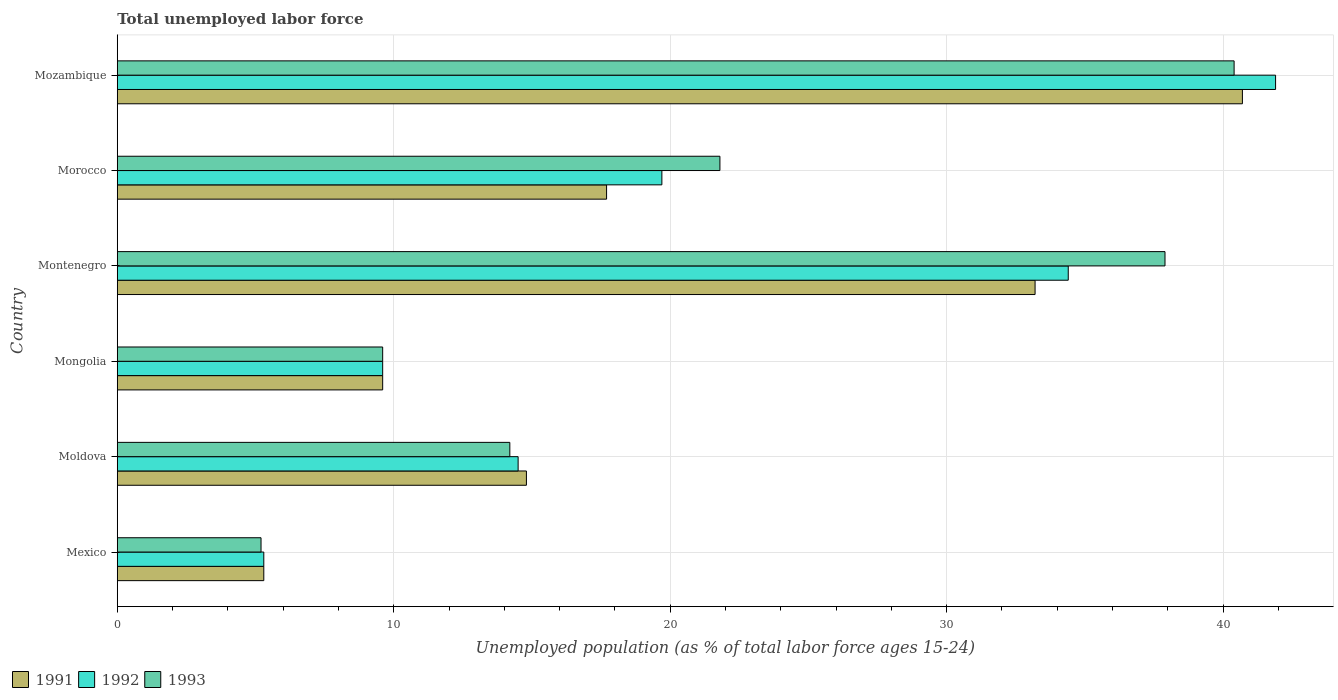How many different coloured bars are there?
Your answer should be compact. 3. How many bars are there on the 4th tick from the top?
Give a very brief answer. 3. How many bars are there on the 6th tick from the bottom?
Give a very brief answer. 3. What is the label of the 3rd group of bars from the top?
Offer a very short reply. Montenegro. In how many cases, is the number of bars for a given country not equal to the number of legend labels?
Keep it short and to the point. 0. What is the percentage of unemployed population in in 1992 in Morocco?
Give a very brief answer. 19.7. Across all countries, what is the maximum percentage of unemployed population in in 1991?
Give a very brief answer. 40.7. Across all countries, what is the minimum percentage of unemployed population in in 1992?
Provide a short and direct response. 5.3. In which country was the percentage of unemployed population in in 1993 maximum?
Ensure brevity in your answer.  Mozambique. What is the total percentage of unemployed population in in 1993 in the graph?
Give a very brief answer. 129.1. What is the difference between the percentage of unemployed population in in 1992 in Mexico and that in Montenegro?
Ensure brevity in your answer.  -29.1. What is the difference between the percentage of unemployed population in in 1992 in Morocco and the percentage of unemployed population in in 1993 in Mexico?
Provide a short and direct response. 14.5. What is the average percentage of unemployed population in in 1991 per country?
Ensure brevity in your answer.  20.22. What is the ratio of the percentage of unemployed population in in 1992 in Mexico to that in Mongolia?
Your response must be concise. 0.55. What is the difference between the highest and the lowest percentage of unemployed population in in 1991?
Give a very brief answer. 35.4. In how many countries, is the percentage of unemployed population in in 1993 greater than the average percentage of unemployed population in in 1993 taken over all countries?
Make the answer very short. 3. What does the 2nd bar from the bottom in Mongolia represents?
Provide a succinct answer. 1992. How many bars are there?
Provide a succinct answer. 18. Are the values on the major ticks of X-axis written in scientific E-notation?
Give a very brief answer. No. Does the graph contain any zero values?
Ensure brevity in your answer.  No. Does the graph contain grids?
Give a very brief answer. Yes. Where does the legend appear in the graph?
Give a very brief answer. Bottom left. How many legend labels are there?
Offer a very short reply. 3. How are the legend labels stacked?
Make the answer very short. Horizontal. What is the title of the graph?
Make the answer very short. Total unemployed labor force. What is the label or title of the X-axis?
Offer a very short reply. Unemployed population (as % of total labor force ages 15-24). What is the label or title of the Y-axis?
Make the answer very short. Country. What is the Unemployed population (as % of total labor force ages 15-24) of 1991 in Mexico?
Offer a very short reply. 5.3. What is the Unemployed population (as % of total labor force ages 15-24) in 1992 in Mexico?
Offer a terse response. 5.3. What is the Unemployed population (as % of total labor force ages 15-24) of 1993 in Mexico?
Provide a succinct answer. 5.2. What is the Unemployed population (as % of total labor force ages 15-24) in 1991 in Moldova?
Keep it short and to the point. 14.8. What is the Unemployed population (as % of total labor force ages 15-24) in 1993 in Moldova?
Offer a very short reply. 14.2. What is the Unemployed population (as % of total labor force ages 15-24) of 1991 in Mongolia?
Your answer should be very brief. 9.6. What is the Unemployed population (as % of total labor force ages 15-24) of 1992 in Mongolia?
Your response must be concise. 9.6. What is the Unemployed population (as % of total labor force ages 15-24) in 1993 in Mongolia?
Your answer should be compact. 9.6. What is the Unemployed population (as % of total labor force ages 15-24) in 1991 in Montenegro?
Provide a succinct answer. 33.2. What is the Unemployed population (as % of total labor force ages 15-24) in 1992 in Montenegro?
Keep it short and to the point. 34.4. What is the Unemployed population (as % of total labor force ages 15-24) in 1993 in Montenegro?
Make the answer very short. 37.9. What is the Unemployed population (as % of total labor force ages 15-24) of 1991 in Morocco?
Provide a short and direct response. 17.7. What is the Unemployed population (as % of total labor force ages 15-24) of 1992 in Morocco?
Give a very brief answer. 19.7. What is the Unemployed population (as % of total labor force ages 15-24) in 1993 in Morocco?
Your answer should be very brief. 21.8. What is the Unemployed population (as % of total labor force ages 15-24) of 1991 in Mozambique?
Offer a very short reply. 40.7. What is the Unemployed population (as % of total labor force ages 15-24) of 1992 in Mozambique?
Provide a short and direct response. 41.9. What is the Unemployed population (as % of total labor force ages 15-24) of 1993 in Mozambique?
Your answer should be compact. 40.4. Across all countries, what is the maximum Unemployed population (as % of total labor force ages 15-24) of 1991?
Make the answer very short. 40.7. Across all countries, what is the maximum Unemployed population (as % of total labor force ages 15-24) of 1992?
Your answer should be very brief. 41.9. Across all countries, what is the maximum Unemployed population (as % of total labor force ages 15-24) of 1993?
Give a very brief answer. 40.4. Across all countries, what is the minimum Unemployed population (as % of total labor force ages 15-24) in 1991?
Your response must be concise. 5.3. Across all countries, what is the minimum Unemployed population (as % of total labor force ages 15-24) of 1992?
Keep it short and to the point. 5.3. Across all countries, what is the minimum Unemployed population (as % of total labor force ages 15-24) in 1993?
Keep it short and to the point. 5.2. What is the total Unemployed population (as % of total labor force ages 15-24) of 1991 in the graph?
Keep it short and to the point. 121.3. What is the total Unemployed population (as % of total labor force ages 15-24) of 1992 in the graph?
Offer a very short reply. 125.4. What is the total Unemployed population (as % of total labor force ages 15-24) of 1993 in the graph?
Give a very brief answer. 129.1. What is the difference between the Unemployed population (as % of total labor force ages 15-24) in 1992 in Mexico and that in Moldova?
Your response must be concise. -9.2. What is the difference between the Unemployed population (as % of total labor force ages 15-24) of 1993 in Mexico and that in Moldova?
Offer a terse response. -9. What is the difference between the Unemployed population (as % of total labor force ages 15-24) of 1991 in Mexico and that in Mongolia?
Your answer should be very brief. -4.3. What is the difference between the Unemployed population (as % of total labor force ages 15-24) in 1993 in Mexico and that in Mongolia?
Your answer should be very brief. -4.4. What is the difference between the Unemployed population (as % of total labor force ages 15-24) of 1991 in Mexico and that in Montenegro?
Offer a very short reply. -27.9. What is the difference between the Unemployed population (as % of total labor force ages 15-24) in 1992 in Mexico and that in Montenegro?
Give a very brief answer. -29.1. What is the difference between the Unemployed population (as % of total labor force ages 15-24) in 1993 in Mexico and that in Montenegro?
Make the answer very short. -32.7. What is the difference between the Unemployed population (as % of total labor force ages 15-24) of 1991 in Mexico and that in Morocco?
Provide a short and direct response. -12.4. What is the difference between the Unemployed population (as % of total labor force ages 15-24) of 1992 in Mexico and that in Morocco?
Offer a very short reply. -14.4. What is the difference between the Unemployed population (as % of total labor force ages 15-24) of 1993 in Mexico and that in Morocco?
Make the answer very short. -16.6. What is the difference between the Unemployed population (as % of total labor force ages 15-24) in 1991 in Mexico and that in Mozambique?
Give a very brief answer. -35.4. What is the difference between the Unemployed population (as % of total labor force ages 15-24) in 1992 in Mexico and that in Mozambique?
Provide a succinct answer. -36.6. What is the difference between the Unemployed population (as % of total labor force ages 15-24) of 1993 in Mexico and that in Mozambique?
Your response must be concise. -35.2. What is the difference between the Unemployed population (as % of total labor force ages 15-24) of 1991 in Moldova and that in Mongolia?
Offer a very short reply. 5.2. What is the difference between the Unemployed population (as % of total labor force ages 15-24) of 1992 in Moldova and that in Mongolia?
Give a very brief answer. 4.9. What is the difference between the Unemployed population (as % of total labor force ages 15-24) in 1993 in Moldova and that in Mongolia?
Your response must be concise. 4.6. What is the difference between the Unemployed population (as % of total labor force ages 15-24) of 1991 in Moldova and that in Montenegro?
Offer a terse response. -18.4. What is the difference between the Unemployed population (as % of total labor force ages 15-24) in 1992 in Moldova and that in Montenegro?
Offer a very short reply. -19.9. What is the difference between the Unemployed population (as % of total labor force ages 15-24) in 1993 in Moldova and that in Montenegro?
Provide a succinct answer. -23.7. What is the difference between the Unemployed population (as % of total labor force ages 15-24) of 1991 in Moldova and that in Morocco?
Provide a short and direct response. -2.9. What is the difference between the Unemployed population (as % of total labor force ages 15-24) in 1993 in Moldova and that in Morocco?
Your answer should be compact. -7.6. What is the difference between the Unemployed population (as % of total labor force ages 15-24) of 1991 in Moldova and that in Mozambique?
Give a very brief answer. -25.9. What is the difference between the Unemployed population (as % of total labor force ages 15-24) of 1992 in Moldova and that in Mozambique?
Provide a succinct answer. -27.4. What is the difference between the Unemployed population (as % of total labor force ages 15-24) of 1993 in Moldova and that in Mozambique?
Your answer should be compact. -26.2. What is the difference between the Unemployed population (as % of total labor force ages 15-24) in 1991 in Mongolia and that in Montenegro?
Offer a terse response. -23.6. What is the difference between the Unemployed population (as % of total labor force ages 15-24) of 1992 in Mongolia and that in Montenegro?
Your response must be concise. -24.8. What is the difference between the Unemployed population (as % of total labor force ages 15-24) of 1993 in Mongolia and that in Montenegro?
Give a very brief answer. -28.3. What is the difference between the Unemployed population (as % of total labor force ages 15-24) of 1991 in Mongolia and that in Morocco?
Ensure brevity in your answer.  -8.1. What is the difference between the Unemployed population (as % of total labor force ages 15-24) in 1993 in Mongolia and that in Morocco?
Offer a very short reply. -12.2. What is the difference between the Unemployed population (as % of total labor force ages 15-24) in 1991 in Mongolia and that in Mozambique?
Make the answer very short. -31.1. What is the difference between the Unemployed population (as % of total labor force ages 15-24) in 1992 in Mongolia and that in Mozambique?
Provide a short and direct response. -32.3. What is the difference between the Unemployed population (as % of total labor force ages 15-24) of 1993 in Mongolia and that in Mozambique?
Provide a short and direct response. -30.8. What is the difference between the Unemployed population (as % of total labor force ages 15-24) of 1991 in Montenegro and that in Morocco?
Provide a succinct answer. 15.5. What is the difference between the Unemployed population (as % of total labor force ages 15-24) of 1993 in Montenegro and that in Morocco?
Give a very brief answer. 16.1. What is the difference between the Unemployed population (as % of total labor force ages 15-24) of 1992 in Montenegro and that in Mozambique?
Your response must be concise. -7.5. What is the difference between the Unemployed population (as % of total labor force ages 15-24) of 1993 in Montenegro and that in Mozambique?
Keep it short and to the point. -2.5. What is the difference between the Unemployed population (as % of total labor force ages 15-24) of 1992 in Morocco and that in Mozambique?
Make the answer very short. -22.2. What is the difference between the Unemployed population (as % of total labor force ages 15-24) of 1993 in Morocco and that in Mozambique?
Provide a succinct answer. -18.6. What is the difference between the Unemployed population (as % of total labor force ages 15-24) of 1992 in Mexico and the Unemployed population (as % of total labor force ages 15-24) of 1993 in Mongolia?
Offer a very short reply. -4.3. What is the difference between the Unemployed population (as % of total labor force ages 15-24) in 1991 in Mexico and the Unemployed population (as % of total labor force ages 15-24) in 1992 in Montenegro?
Your answer should be very brief. -29.1. What is the difference between the Unemployed population (as % of total labor force ages 15-24) in 1991 in Mexico and the Unemployed population (as % of total labor force ages 15-24) in 1993 in Montenegro?
Ensure brevity in your answer.  -32.6. What is the difference between the Unemployed population (as % of total labor force ages 15-24) in 1992 in Mexico and the Unemployed population (as % of total labor force ages 15-24) in 1993 in Montenegro?
Your response must be concise. -32.6. What is the difference between the Unemployed population (as % of total labor force ages 15-24) of 1991 in Mexico and the Unemployed population (as % of total labor force ages 15-24) of 1992 in Morocco?
Your response must be concise. -14.4. What is the difference between the Unemployed population (as % of total labor force ages 15-24) in 1991 in Mexico and the Unemployed population (as % of total labor force ages 15-24) in 1993 in Morocco?
Offer a very short reply. -16.5. What is the difference between the Unemployed population (as % of total labor force ages 15-24) of 1992 in Mexico and the Unemployed population (as % of total labor force ages 15-24) of 1993 in Morocco?
Your answer should be compact. -16.5. What is the difference between the Unemployed population (as % of total labor force ages 15-24) in 1991 in Mexico and the Unemployed population (as % of total labor force ages 15-24) in 1992 in Mozambique?
Your answer should be compact. -36.6. What is the difference between the Unemployed population (as % of total labor force ages 15-24) of 1991 in Mexico and the Unemployed population (as % of total labor force ages 15-24) of 1993 in Mozambique?
Provide a succinct answer. -35.1. What is the difference between the Unemployed population (as % of total labor force ages 15-24) in 1992 in Mexico and the Unemployed population (as % of total labor force ages 15-24) in 1993 in Mozambique?
Give a very brief answer. -35.1. What is the difference between the Unemployed population (as % of total labor force ages 15-24) of 1991 in Moldova and the Unemployed population (as % of total labor force ages 15-24) of 1993 in Mongolia?
Your answer should be compact. 5.2. What is the difference between the Unemployed population (as % of total labor force ages 15-24) in 1991 in Moldova and the Unemployed population (as % of total labor force ages 15-24) in 1992 in Montenegro?
Your answer should be very brief. -19.6. What is the difference between the Unemployed population (as % of total labor force ages 15-24) in 1991 in Moldova and the Unemployed population (as % of total labor force ages 15-24) in 1993 in Montenegro?
Your response must be concise. -23.1. What is the difference between the Unemployed population (as % of total labor force ages 15-24) in 1992 in Moldova and the Unemployed population (as % of total labor force ages 15-24) in 1993 in Montenegro?
Your answer should be compact. -23.4. What is the difference between the Unemployed population (as % of total labor force ages 15-24) of 1991 in Moldova and the Unemployed population (as % of total labor force ages 15-24) of 1992 in Morocco?
Provide a short and direct response. -4.9. What is the difference between the Unemployed population (as % of total labor force ages 15-24) in 1991 in Moldova and the Unemployed population (as % of total labor force ages 15-24) in 1993 in Morocco?
Provide a succinct answer. -7. What is the difference between the Unemployed population (as % of total labor force ages 15-24) in 1992 in Moldova and the Unemployed population (as % of total labor force ages 15-24) in 1993 in Morocco?
Ensure brevity in your answer.  -7.3. What is the difference between the Unemployed population (as % of total labor force ages 15-24) of 1991 in Moldova and the Unemployed population (as % of total labor force ages 15-24) of 1992 in Mozambique?
Provide a short and direct response. -27.1. What is the difference between the Unemployed population (as % of total labor force ages 15-24) in 1991 in Moldova and the Unemployed population (as % of total labor force ages 15-24) in 1993 in Mozambique?
Offer a terse response. -25.6. What is the difference between the Unemployed population (as % of total labor force ages 15-24) of 1992 in Moldova and the Unemployed population (as % of total labor force ages 15-24) of 1993 in Mozambique?
Make the answer very short. -25.9. What is the difference between the Unemployed population (as % of total labor force ages 15-24) in 1991 in Mongolia and the Unemployed population (as % of total labor force ages 15-24) in 1992 in Montenegro?
Make the answer very short. -24.8. What is the difference between the Unemployed population (as % of total labor force ages 15-24) of 1991 in Mongolia and the Unemployed population (as % of total labor force ages 15-24) of 1993 in Montenegro?
Provide a succinct answer. -28.3. What is the difference between the Unemployed population (as % of total labor force ages 15-24) in 1992 in Mongolia and the Unemployed population (as % of total labor force ages 15-24) in 1993 in Montenegro?
Your answer should be compact. -28.3. What is the difference between the Unemployed population (as % of total labor force ages 15-24) of 1992 in Mongolia and the Unemployed population (as % of total labor force ages 15-24) of 1993 in Morocco?
Your response must be concise. -12.2. What is the difference between the Unemployed population (as % of total labor force ages 15-24) of 1991 in Mongolia and the Unemployed population (as % of total labor force ages 15-24) of 1992 in Mozambique?
Make the answer very short. -32.3. What is the difference between the Unemployed population (as % of total labor force ages 15-24) of 1991 in Mongolia and the Unemployed population (as % of total labor force ages 15-24) of 1993 in Mozambique?
Offer a very short reply. -30.8. What is the difference between the Unemployed population (as % of total labor force ages 15-24) of 1992 in Mongolia and the Unemployed population (as % of total labor force ages 15-24) of 1993 in Mozambique?
Give a very brief answer. -30.8. What is the difference between the Unemployed population (as % of total labor force ages 15-24) of 1991 in Montenegro and the Unemployed population (as % of total labor force ages 15-24) of 1993 in Morocco?
Your response must be concise. 11.4. What is the difference between the Unemployed population (as % of total labor force ages 15-24) of 1992 in Montenegro and the Unemployed population (as % of total labor force ages 15-24) of 1993 in Morocco?
Ensure brevity in your answer.  12.6. What is the difference between the Unemployed population (as % of total labor force ages 15-24) of 1991 in Morocco and the Unemployed population (as % of total labor force ages 15-24) of 1992 in Mozambique?
Offer a very short reply. -24.2. What is the difference between the Unemployed population (as % of total labor force ages 15-24) of 1991 in Morocco and the Unemployed population (as % of total labor force ages 15-24) of 1993 in Mozambique?
Ensure brevity in your answer.  -22.7. What is the difference between the Unemployed population (as % of total labor force ages 15-24) of 1992 in Morocco and the Unemployed population (as % of total labor force ages 15-24) of 1993 in Mozambique?
Offer a very short reply. -20.7. What is the average Unemployed population (as % of total labor force ages 15-24) in 1991 per country?
Your answer should be very brief. 20.22. What is the average Unemployed population (as % of total labor force ages 15-24) in 1992 per country?
Make the answer very short. 20.9. What is the average Unemployed population (as % of total labor force ages 15-24) in 1993 per country?
Provide a succinct answer. 21.52. What is the difference between the Unemployed population (as % of total labor force ages 15-24) of 1991 and Unemployed population (as % of total labor force ages 15-24) of 1993 in Mexico?
Your response must be concise. 0.1. What is the difference between the Unemployed population (as % of total labor force ages 15-24) in 1992 and Unemployed population (as % of total labor force ages 15-24) in 1993 in Mexico?
Your answer should be very brief. 0.1. What is the difference between the Unemployed population (as % of total labor force ages 15-24) of 1991 and Unemployed population (as % of total labor force ages 15-24) of 1993 in Moldova?
Keep it short and to the point. 0.6. What is the difference between the Unemployed population (as % of total labor force ages 15-24) in 1992 and Unemployed population (as % of total labor force ages 15-24) in 1993 in Moldova?
Keep it short and to the point. 0.3. What is the difference between the Unemployed population (as % of total labor force ages 15-24) in 1992 and Unemployed population (as % of total labor force ages 15-24) in 1993 in Mongolia?
Provide a short and direct response. 0. What is the difference between the Unemployed population (as % of total labor force ages 15-24) of 1992 and Unemployed population (as % of total labor force ages 15-24) of 1993 in Montenegro?
Make the answer very short. -3.5. What is the difference between the Unemployed population (as % of total labor force ages 15-24) in 1991 and Unemployed population (as % of total labor force ages 15-24) in 1993 in Morocco?
Provide a succinct answer. -4.1. What is the difference between the Unemployed population (as % of total labor force ages 15-24) of 1992 and Unemployed population (as % of total labor force ages 15-24) of 1993 in Morocco?
Your answer should be very brief. -2.1. What is the difference between the Unemployed population (as % of total labor force ages 15-24) of 1991 and Unemployed population (as % of total labor force ages 15-24) of 1992 in Mozambique?
Keep it short and to the point. -1.2. What is the ratio of the Unemployed population (as % of total labor force ages 15-24) of 1991 in Mexico to that in Moldova?
Ensure brevity in your answer.  0.36. What is the ratio of the Unemployed population (as % of total labor force ages 15-24) of 1992 in Mexico to that in Moldova?
Offer a terse response. 0.37. What is the ratio of the Unemployed population (as % of total labor force ages 15-24) in 1993 in Mexico to that in Moldova?
Make the answer very short. 0.37. What is the ratio of the Unemployed population (as % of total labor force ages 15-24) in 1991 in Mexico to that in Mongolia?
Offer a very short reply. 0.55. What is the ratio of the Unemployed population (as % of total labor force ages 15-24) of 1992 in Mexico to that in Mongolia?
Your answer should be very brief. 0.55. What is the ratio of the Unemployed population (as % of total labor force ages 15-24) of 1993 in Mexico to that in Mongolia?
Offer a terse response. 0.54. What is the ratio of the Unemployed population (as % of total labor force ages 15-24) of 1991 in Mexico to that in Montenegro?
Ensure brevity in your answer.  0.16. What is the ratio of the Unemployed population (as % of total labor force ages 15-24) of 1992 in Mexico to that in Montenegro?
Ensure brevity in your answer.  0.15. What is the ratio of the Unemployed population (as % of total labor force ages 15-24) in 1993 in Mexico to that in Montenegro?
Keep it short and to the point. 0.14. What is the ratio of the Unemployed population (as % of total labor force ages 15-24) in 1991 in Mexico to that in Morocco?
Your answer should be compact. 0.3. What is the ratio of the Unemployed population (as % of total labor force ages 15-24) of 1992 in Mexico to that in Morocco?
Your response must be concise. 0.27. What is the ratio of the Unemployed population (as % of total labor force ages 15-24) of 1993 in Mexico to that in Morocco?
Ensure brevity in your answer.  0.24. What is the ratio of the Unemployed population (as % of total labor force ages 15-24) in 1991 in Mexico to that in Mozambique?
Provide a succinct answer. 0.13. What is the ratio of the Unemployed population (as % of total labor force ages 15-24) in 1992 in Mexico to that in Mozambique?
Provide a short and direct response. 0.13. What is the ratio of the Unemployed population (as % of total labor force ages 15-24) in 1993 in Mexico to that in Mozambique?
Keep it short and to the point. 0.13. What is the ratio of the Unemployed population (as % of total labor force ages 15-24) of 1991 in Moldova to that in Mongolia?
Make the answer very short. 1.54. What is the ratio of the Unemployed population (as % of total labor force ages 15-24) of 1992 in Moldova to that in Mongolia?
Ensure brevity in your answer.  1.51. What is the ratio of the Unemployed population (as % of total labor force ages 15-24) of 1993 in Moldova to that in Mongolia?
Offer a very short reply. 1.48. What is the ratio of the Unemployed population (as % of total labor force ages 15-24) of 1991 in Moldova to that in Montenegro?
Provide a short and direct response. 0.45. What is the ratio of the Unemployed population (as % of total labor force ages 15-24) in 1992 in Moldova to that in Montenegro?
Provide a short and direct response. 0.42. What is the ratio of the Unemployed population (as % of total labor force ages 15-24) of 1993 in Moldova to that in Montenegro?
Your answer should be very brief. 0.37. What is the ratio of the Unemployed population (as % of total labor force ages 15-24) in 1991 in Moldova to that in Morocco?
Your answer should be very brief. 0.84. What is the ratio of the Unemployed population (as % of total labor force ages 15-24) in 1992 in Moldova to that in Morocco?
Your answer should be compact. 0.74. What is the ratio of the Unemployed population (as % of total labor force ages 15-24) of 1993 in Moldova to that in Morocco?
Offer a terse response. 0.65. What is the ratio of the Unemployed population (as % of total labor force ages 15-24) in 1991 in Moldova to that in Mozambique?
Give a very brief answer. 0.36. What is the ratio of the Unemployed population (as % of total labor force ages 15-24) in 1992 in Moldova to that in Mozambique?
Provide a succinct answer. 0.35. What is the ratio of the Unemployed population (as % of total labor force ages 15-24) of 1993 in Moldova to that in Mozambique?
Your response must be concise. 0.35. What is the ratio of the Unemployed population (as % of total labor force ages 15-24) of 1991 in Mongolia to that in Montenegro?
Provide a short and direct response. 0.29. What is the ratio of the Unemployed population (as % of total labor force ages 15-24) in 1992 in Mongolia to that in Montenegro?
Provide a short and direct response. 0.28. What is the ratio of the Unemployed population (as % of total labor force ages 15-24) of 1993 in Mongolia to that in Montenegro?
Your response must be concise. 0.25. What is the ratio of the Unemployed population (as % of total labor force ages 15-24) of 1991 in Mongolia to that in Morocco?
Make the answer very short. 0.54. What is the ratio of the Unemployed population (as % of total labor force ages 15-24) of 1992 in Mongolia to that in Morocco?
Your response must be concise. 0.49. What is the ratio of the Unemployed population (as % of total labor force ages 15-24) in 1993 in Mongolia to that in Morocco?
Provide a succinct answer. 0.44. What is the ratio of the Unemployed population (as % of total labor force ages 15-24) of 1991 in Mongolia to that in Mozambique?
Provide a short and direct response. 0.24. What is the ratio of the Unemployed population (as % of total labor force ages 15-24) in 1992 in Mongolia to that in Mozambique?
Provide a succinct answer. 0.23. What is the ratio of the Unemployed population (as % of total labor force ages 15-24) in 1993 in Mongolia to that in Mozambique?
Provide a succinct answer. 0.24. What is the ratio of the Unemployed population (as % of total labor force ages 15-24) in 1991 in Montenegro to that in Morocco?
Provide a succinct answer. 1.88. What is the ratio of the Unemployed population (as % of total labor force ages 15-24) of 1992 in Montenegro to that in Morocco?
Offer a terse response. 1.75. What is the ratio of the Unemployed population (as % of total labor force ages 15-24) of 1993 in Montenegro to that in Morocco?
Your answer should be very brief. 1.74. What is the ratio of the Unemployed population (as % of total labor force ages 15-24) of 1991 in Montenegro to that in Mozambique?
Give a very brief answer. 0.82. What is the ratio of the Unemployed population (as % of total labor force ages 15-24) of 1992 in Montenegro to that in Mozambique?
Offer a very short reply. 0.82. What is the ratio of the Unemployed population (as % of total labor force ages 15-24) of 1993 in Montenegro to that in Mozambique?
Provide a succinct answer. 0.94. What is the ratio of the Unemployed population (as % of total labor force ages 15-24) of 1991 in Morocco to that in Mozambique?
Provide a succinct answer. 0.43. What is the ratio of the Unemployed population (as % of total labor force ages 15-24) of 1992 in Morocco to that in Mozambique?
Keep it short and to the point. 0.47. What is the ratio of the Unemployed population (as % of total labor force ages 15-24) in 1993 in Morocco to that in Mozambique?
Keep it short and to the point. 0.54. What is the difference between the highest and the second highest Unemployed population (as % of total labor force ages 15-24) of 1992?
Keep it short and to the point. 7.5. What is the difference between the highest and the lowest Unemployed population (as % of total labor force ages 15-24) in 1991?
Make the answer very short. 35.4. What is the difference between the highest and the lowest Unemployed population (as % of total labor force ages 15-24) in 1992?
Offer a very short reply. 36.6. What is the difference between the highest and the lowest Unemployed population (as % of total labor force ages 15-24) of 1993?
Your answer should be compact. 35.2. 